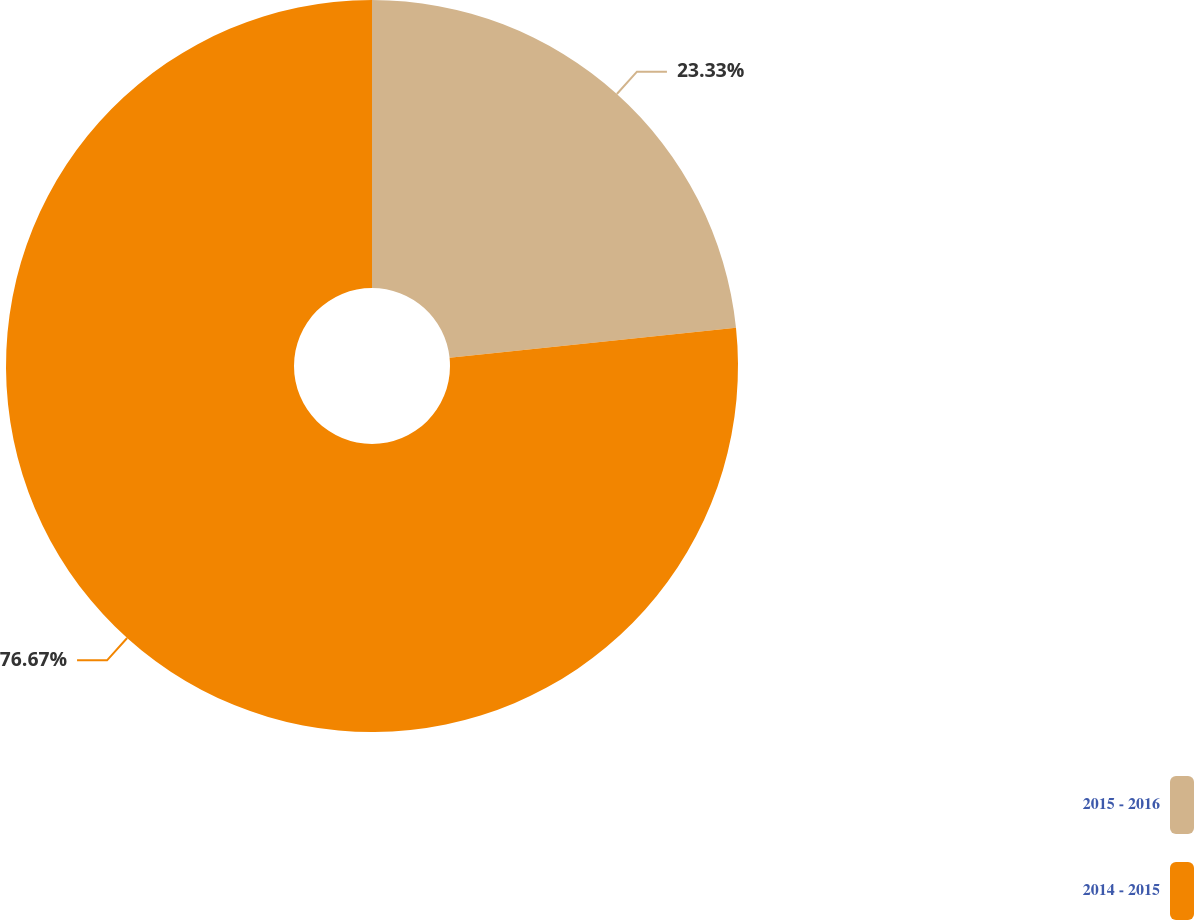Convert chart to OTSL. <chart><loc_0><loc_0><loc_500><loc_500><pie_chart><fcel>2015 - 2016<fcel>2014 - 2015<nl><fcel>23.33%<fcel>76.67%<nl></chart> 